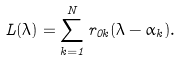Convert formula to latex. <formula><loc_0><loc_0><loc_500><loc_500>L ( \lambda ) = \sum _ { k = 1 } ^ { N } r _ { 0 k } ( \lambda - \alpha _ { k } ) .</formula> 